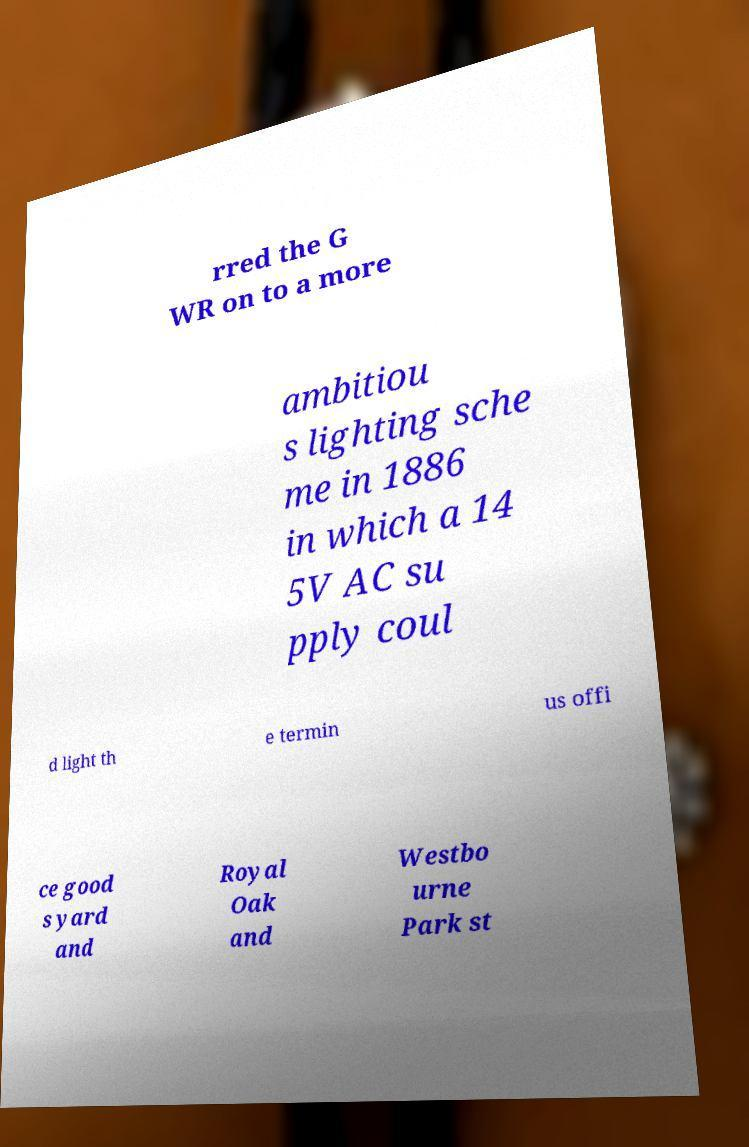Could you assist in decoding the text presented in this image and type it out clearly? rred the G WR on to a more ambitiou s lighting sche me in 1886 in which a 14 5V AC su pply coul d light th e termin us offi ce good s yard and Royal Oak and Westbo urne Park st 